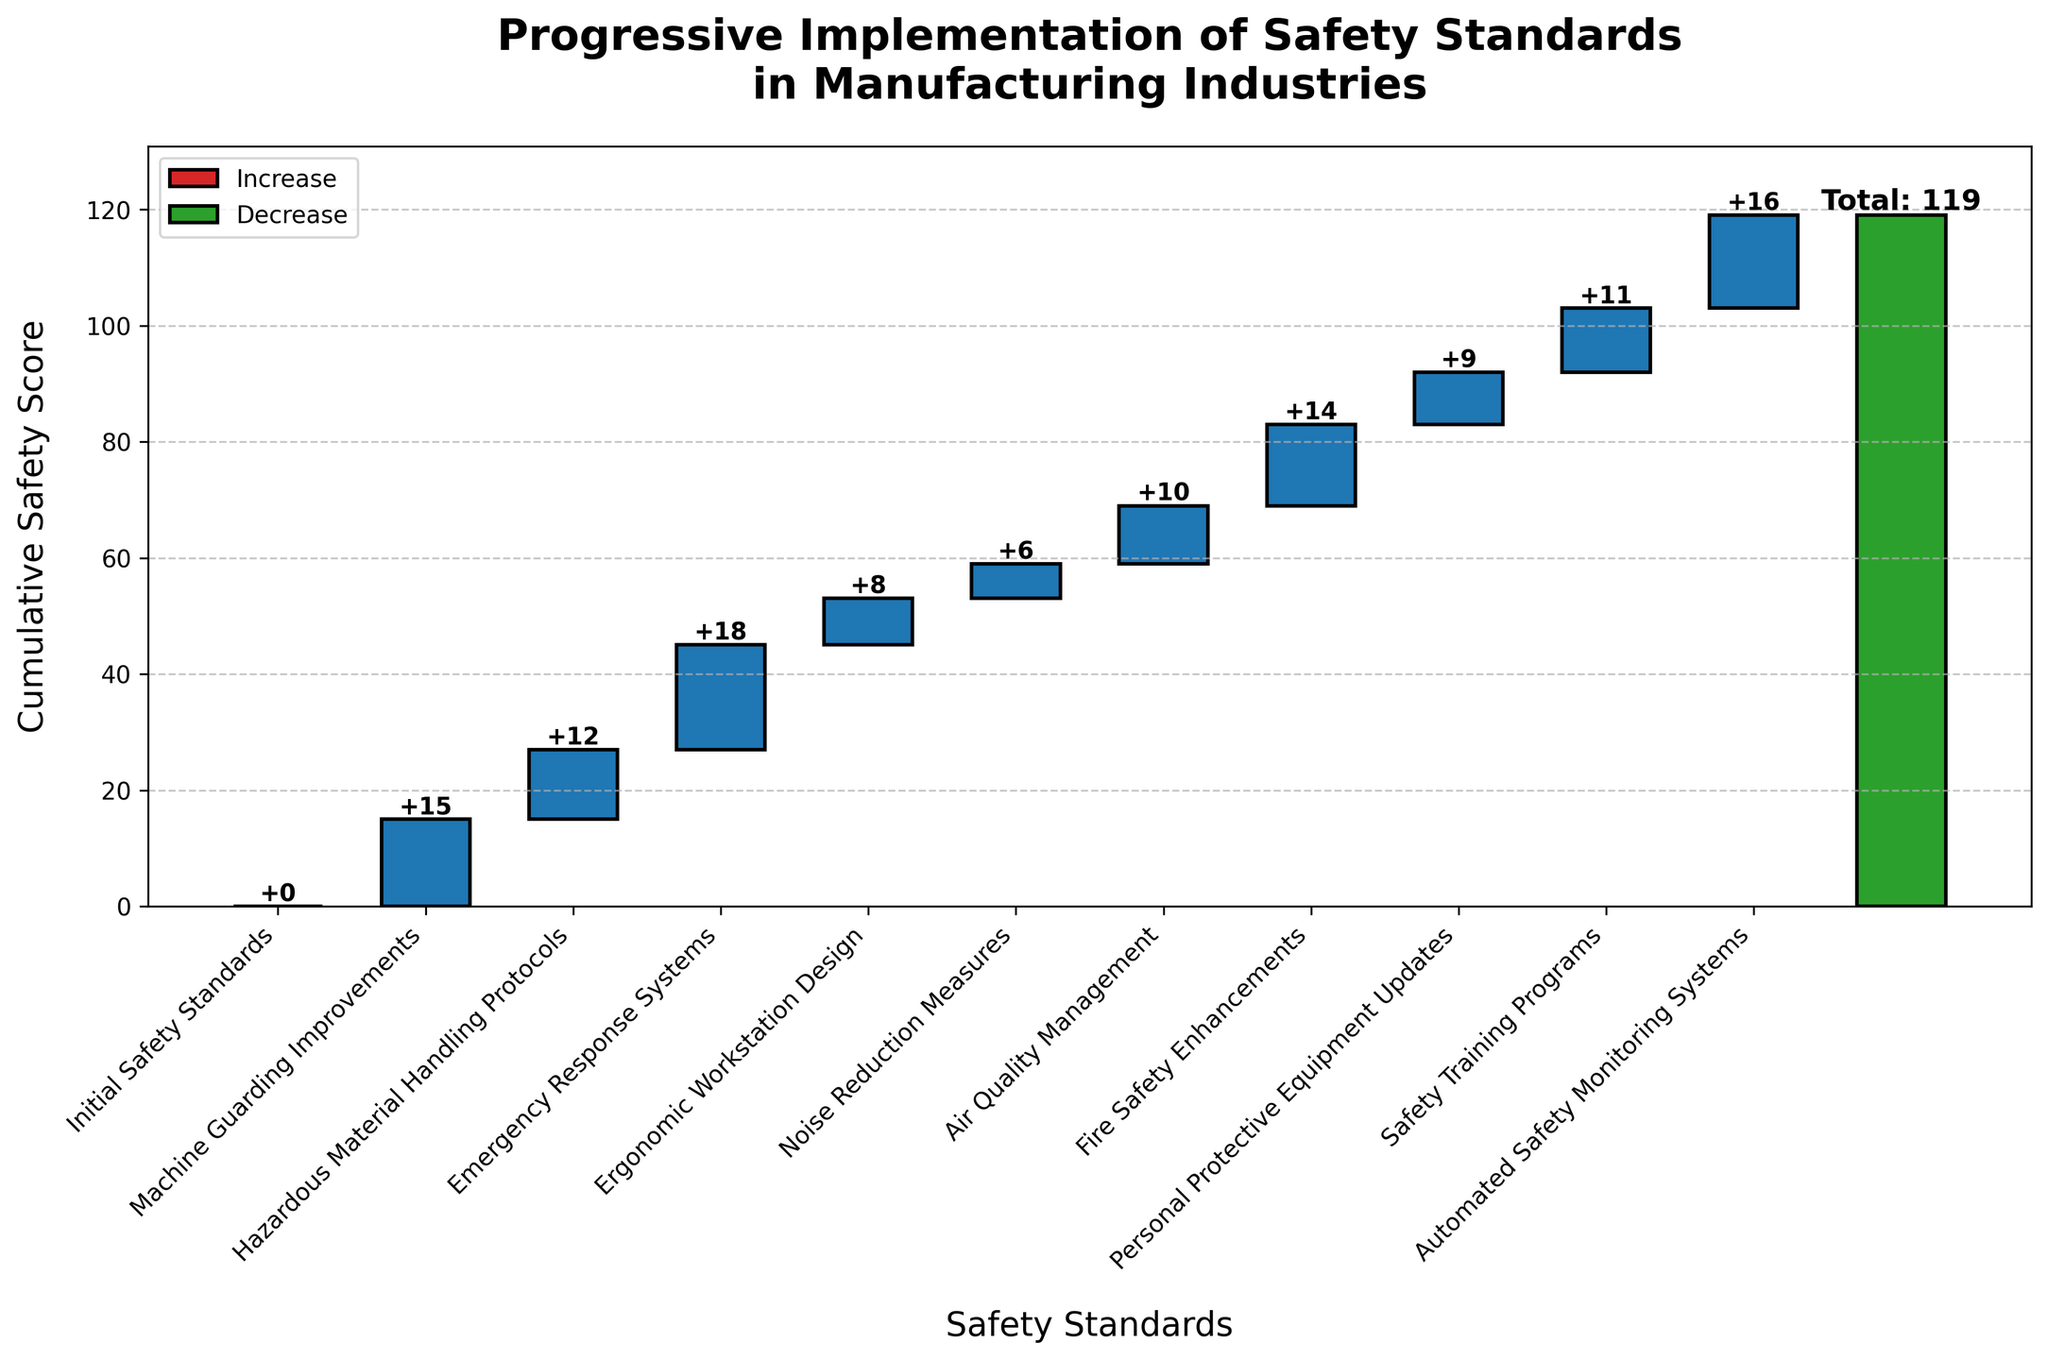What is the total cumulative safety score for 2021? The total cumulative safety score is labeled as 'Total Safety Standard Implementation' in 2021, which is positioned at the end of the waterfall chart.
Answer: 119 Which year had the highest incremental increase in safety score? The height of each bar represents the incremental increase for each year. The year 2013 (Emergency Response Systems) has the highest incremental increase as its bar is the tallest.
Answer: 2013 What is the cumulative safety score after implementing Emergency Response Systems in 2013? The cumulative safety score after implementing Emergency Response Systems in 2013 includes the sum of the incremental increases up to that year: 15 (2011) + 12 (2012) + 18 (2013) = 45.
Answer: 45 How many categories contributed to the total safety score by 2021? Excluding the total, count the number of unique categories listed on the x-axis.
Answer: 10 What is the combined safety score contribution of Machine Guarding Improvements and Hazardous Material Handling Protocols? Add the individual values of the two categories: 15 (2011) + 12 (2012) = 27.
Answer: 27 What was the contribution of Fire Safety Enhancements to the cumulative score? Fire Safety Enhancements from 2017 is marked with a value of 14.
Answer: 14 Compare the safety score contributions of Personal Protective Equipment Updates and Noise Reduction Measures. Which one is higher and by how much? Personal Protective Equipment Updates (2018) contributed 9, while Noise Reduction Measures (2015) contributed 6. The difference is 9 - 6 = 3.
Answer: Personal Protective Equipment Updates is higher by 3 How does the cumulative safety score change from 2010 to 2012? The cumulative score starts at 0 in 2010 and by 2012 includes the contributions of Machine Guarding Improvements and Hazardous Material Handling Protocols: 15 (2011) + 12 (2012) = 27.
Answer: 27 What is the percentage increase in the cumulative safety score from 2019 to 2020? From 2019 with Safety Training Programs (11) to 2020 with Automated Safety Monitoring Systems (16) is an increase of (16 / 11) * 100 - 100.
Answer: 45.45% Identify the years when the cumulative safety score increment was less than 10. Check the values of all increments and identify the years where values are less than 10: Ergonomic Workstation Design (2014 – 8), Noise Reduction Measures (2015 – 6), Personal Protective Equipment Updates (2018 – 9).
Answer: 2014, 2015, 2018 